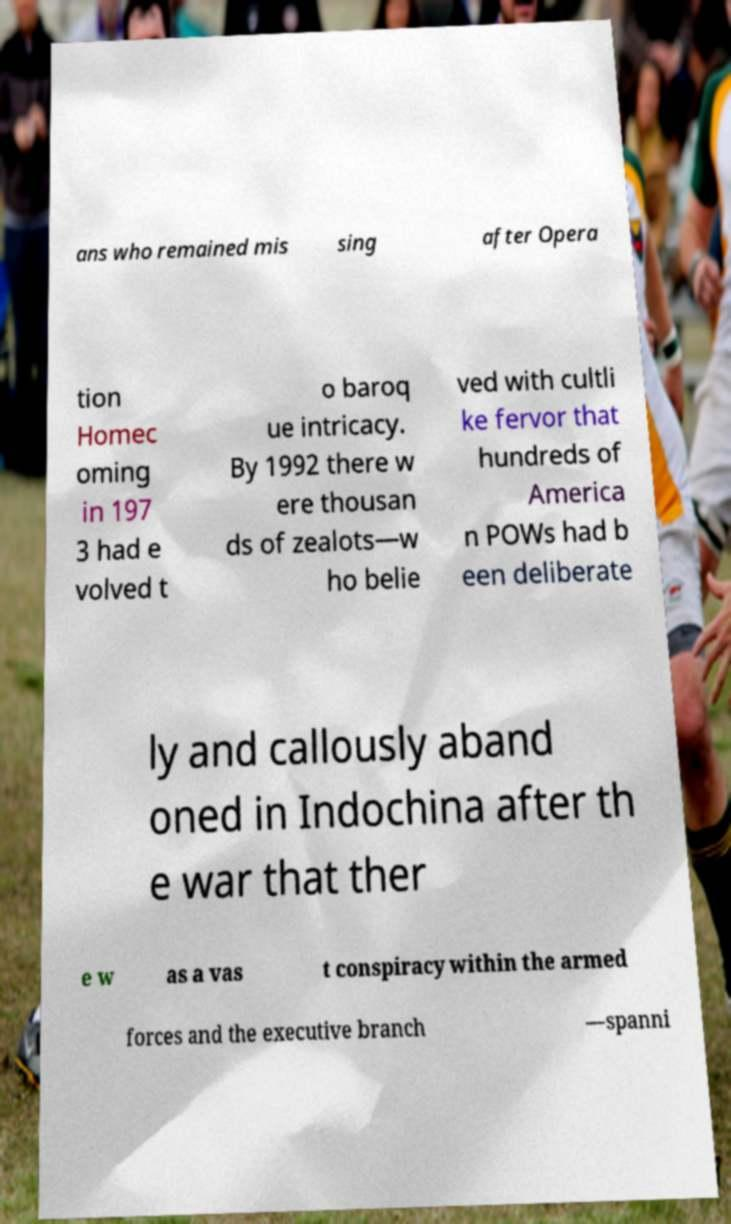For documentation purposes, I need the text within this image transcribed. Could you provide that? ans who remained mis sing after Opera tion Homec oming in 197 3 had e volved t o baroq ue intricacy. By 1992 there w ere thousan ds of zealots—w ho belie ved with cultli ke fervor that hundreds of America n POWs had b een deliberate ly and callously aband oned in Indochina after th e war that ther e w as a vas t conspiracy within the armed forces and the executive branch —spanni 